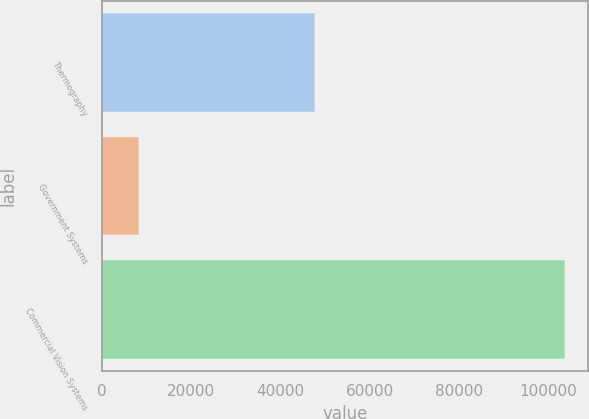Convert chart. <chart><loc_0><loc_0><loc_500><loc_500><bar_chart><fcel>Thermography<fcel>Government Systems<fcel>Commercial Vision Systems<nl><fcel>47658<fcel>8295<fcel>103849<nl></chart> 